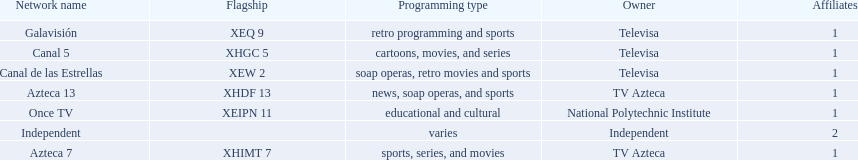What stations show sports? Soap operas, retro movies and sports, retro programming and sports, news, soap operas, and sports. What of these is not affiliated with televisa? Azteca 7. 